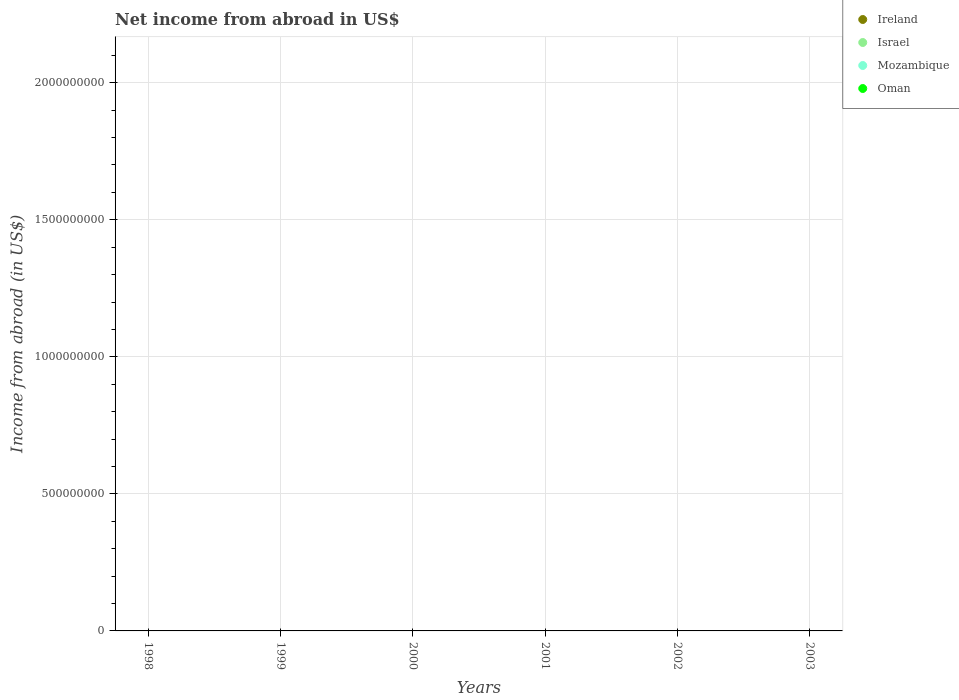Across all years, what is the minimum net income from abroad in Mozambique?
Offer a terse response. 0. What is the total net income from abroad in Ireland in the graph?
Your response must be concise. 0. What is the difference between the net income from abroad in Mozambique in 1998 and the net income from abroad in Israel in 2000?
Ensure brevity in your answer.  0. What is the average net income from abroad in Israel per year?
Make the answer very short. 0. In how many years, is the net income from abroad in Mozambique greater than the average net income from abroad in Mozambique taken over all years?
Provide a succinct answer. 0. Is it the case that in every year, the sum of the net income from abroad in Oman and net income from abroad in Ireland  is greater than the sum of net income from abroad in Israel and net income from abroad in Mozambique?
Your answer should be compact. No. Does the net income from abroad in Mozambique monotonically increase over the years?
Your answer should be compact. No. Is the net income from abroad in Oman strictly less than the net income from abroad in Israel over the years?
Provide a succinct answer. No. How many years are there in the graph?
Provide a short and direct response. 6. Are the values on the major ticks of Y-axis written in scientific E-notation?
Offer a very short reply. No. Where does the legend appear in the graph?
Offer a terse response. Top right. How many legend labels are there?
Offer a very short reply. 4. How are the legend labels stacked?
Give a very brief answer. Vertical. What is the title of the graph?
Offer a terse response. Net income from abroad in US$. Does "Turkmenistan" appear as one of the legend labels in the graph?
Ensure brevity in your answer.  No. What is the label or title of the Y-axis?
Offer a terse response. Income from abroad (in US$). What is the Income from abroad (in US$) in Ireland in 1998?
Offer a terse response. 0. What is the Income from abroad (in US$) in Mozambique in 1998?
Ensure brevity in your answer.  0. What is the Income from abroad (in US$) of Oman in 1998?
Keep it short and to the point. 0. What is the Income from abroad (in US$) in Ireland in 1999?
Ensure brevity in your answer.  0. What is the Income from abroad (in US$) of Israel in 1999?
Your answer should be very brief. 0. What is the Income from abroad (in US$) in Oman in 1999?
Offer a terse response. 0. What is the Income from abroad (in US$) in Ireland in 2000?
Your response must be concise. 0. What is the Income from abroad (in US$) of Israel in 2001?
Give a very brief answer. 0. What is the Income from abroad (in US$) in Mozambique in 2001?
Give a very brief answer. 0. What is the Income from abroad (in US$) in Oman in 2002?
Provide a short and direct response. 0. What is the Income from abroad (in US$) of Israel in 2003?
Your response must be concise. 0. What is the Income from abroad (in US$) of Mozambique in 2003?
Offer a terse response. 0. What is the total Income from abroad (in US$) of Ireland in the graph?
Keep it short and to the point. 0. What is the total Income from abroad (in US$) in Israel in the graph?
Provide a succinct answer. 0. What is the average Income from abroad (in US$) of Ireland per year?
Provide a succinct answer. 0. What is the average Income from abroad (in US$) of Israel per year?
Provide a succinct answer. 0. What is the average Income from abroad (in US$) of Mozambique per year?
Keep it short and to the point. 0. 